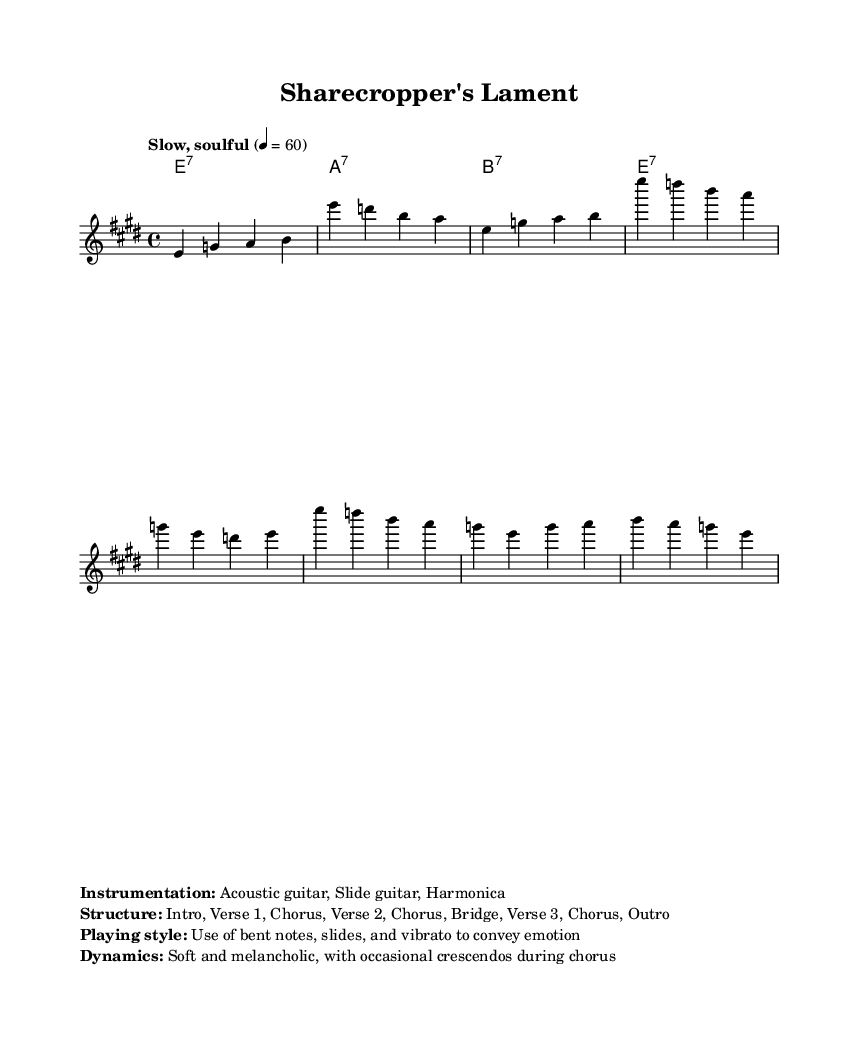What is the key signature of this music? The key signature is indicated with sharps or flats at the beginning of the staff. In this case, it specifies E major, which has four sharps.
Answer: E major What is the time signature of this music? The time signature is shown at the beginning of the music sheet, indicated as a fraction. Here, it is 4 over 4, meaning four beats in each measure.
Answer: 4/4 What is the tempo marking for this piece? The tempo is generally expressed above the staff, describing how fast or slow the piece should be played. In this music, it is marked as "Slow, soulful".
Answer: Slow, soulful How many verses are in the music structure? The structure is laid out in a list format indicating sections. The provided structure contains three verses total.
Answer: Three What style is recommended for playing this piece? The playing style is indicated under the "Instrumentation" section, where it notes specific techniques to use. Here, it suggests the use of bent notes, slides, and vibrato; common in blues.
Answer: Bent notes, slides, and vibrato What musical elements are used in the chorus of this piece? The chorus contains specific notes and chords repeated to establish a thematic signature. Reviewing the sections, it identifies multiple instances of the combination of melodies and harmonies. Here, the chorus features E minor and A minor chords prominently.
Answer: E minor and A minor 